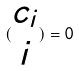<formula> <loc_0><loc_0><loc_500><loc_500>( \begin{matrix} c _ { i } \\ i \end{matrix} ) = 0</formula> 